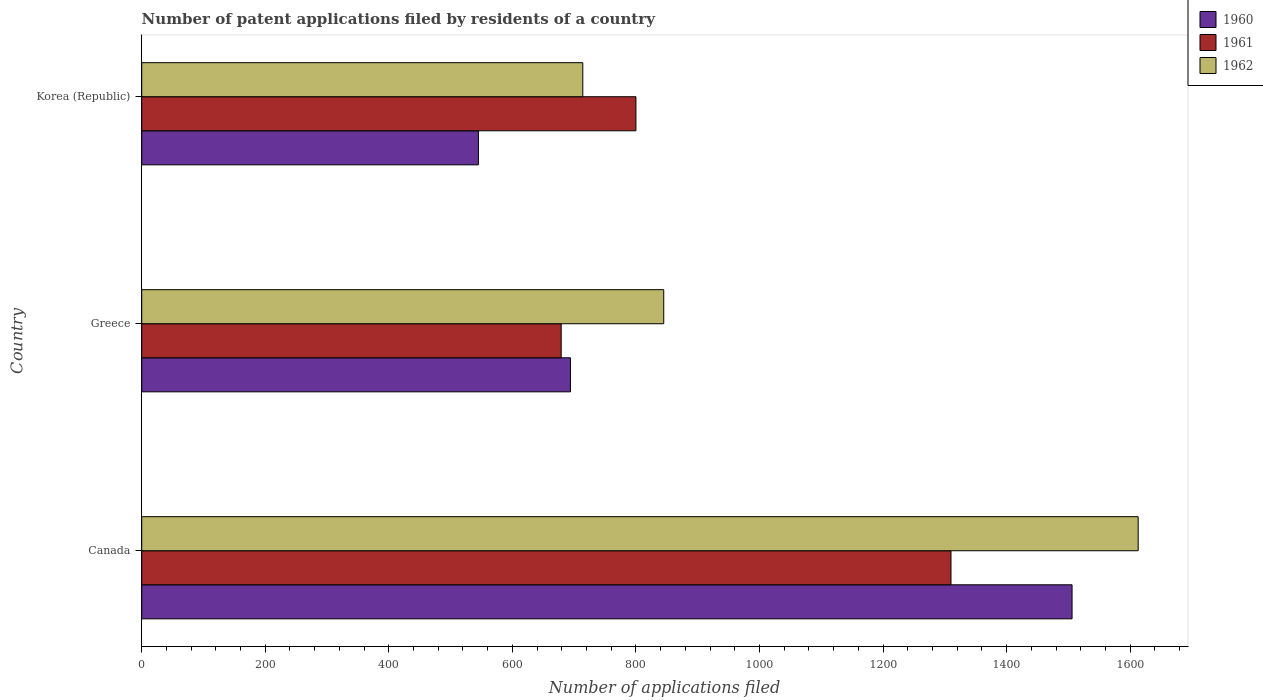How many different coloured bars are there?
Offer a very short reply. 3. What is the label of the 1st group of bars from the top?
Your answer should be very brief. Korea (Republic). What is the number of applications filed in 1962 in Greece?
Your answer should be very brief. 845. Across all countries, what is the maximum number of applications filed in 1960?
Provide a succinct answer. 1506. Across all countries, what is the minimum number of applications filed in 1960?
Provide a short and direct response. 545. What is the total number of applications filed in 1960 in the graph?
Provide a succinct answer. 2745. What is the difference between the number of applications filed in 1962 in Canada and that in Greece?
Your response must be concise. 768. What is the difference between the number of applications filed in 1960 in Canada and the number of applications filed in 1962 in Korea (Republic)?
Your response must be concise. 792. What is the average number of applications filed in 1962 per country?
Make the answer very short. 1057.33. What is the difference between the number of applications filed in 1960 and number of applications filed in 1962 in Korea (Republic)?
Provide a succinct answer. -169. In how many countries, is the number of applications filed in 1962 greater than 880 ?
Offer a terse response. 1. What is the ratio of the number of applications filed in 1962 in Greece to that in Korea (Republic)?
Provide a succinct answer. 1.18. Is the number of applications filed in 1962 in Canada less than that in Greece?
Offer a terse response. No. Is the difference between the number of applications filed in 1960 in Canada and Korea (Republic) greater than the difference between the number of applications filed in 1962 in Canada and Korea (Republic)?
Ensure brevity in your answer.  Yes. What is the difference between the highest and the second highest number of applications filed in 1962?
Offer a very short reply. 768. What is the difference between the highest and the lowest number of applications filed in 1961?
Your answer should be compact. 631. Is the sum of the number of applications filed in 1962 in Canada and Korea (Republic) greater than the maximum number of applications filed in 1960 across all countries?
Your answer should be compact. Yes. How many bars are there?
Offer a terse response. 9. Are all the bars in the graph horizontal?
Keep it short and to the point. Yes. What is the difference between two consecutive major ticks on the X-axis?
Give a very brief answer. 200. Does the graph contain any zero values?
Your answer should be compact. No. How are the legend labels stacked?
Keep it short and to the point. Vertical. What is the title of the graph?
Keep it short and to the point. Number of patent applications filed by residents of a country. Does "2001" appear as one of the legend labels in the graph?
Give a very brief answer. No. What is the label or title of the X-axis?
Offer a terse response. Number of applications filed. What is the Number of applications filed of 1960 in Canada?
Provide a succinct answer. 1506. What is the Number of applications filed of 1961 in Canada?
Make the answer very short. 1310. What is the Number of applications filed in 1962 in Canada?
Ensure brevity in your answer.  1613. What is the Number of applications filed in 1960 in Greece?
Offer a terse response. 694. What is the Number of applications filed in 1961 in Greece?
Provide a short and direct response. 679. What is the Number of applications filed of 1962 in Greece?
Your answer should be compact. 845. What is the Number of applications filed of 1960 in Korea (Republic)?
Your answer should be compact. 545. What is the Number of applications filed in 1961 in Korea (Republic)?
Your response must be concise. 800. What is the Number of applications filed in 1962 in Korea (Republic)?
Offer a very short reply. 714. Across all countries, what is the maximum Number of applications filed of 1960?
Offer a terse response. 1506. Across all countries, what is the maximum Number of applications filed in 1961?
Provide a short and direct response. 1310. Across all countries, what is the maximum Number of applications filed of 1962?
Give a very brief answer. 1613. Across all countries, what is the minimum Number of applications filed of 1960?
Your response must be concise. 545. Across all countries, what is the minimum Number of applications filed in 1961?
Make the answer very short. 679. Across all countries, what is the minimum Number of applications filed of 1962?
Your answer should be very brief. 714. What is the total Number of applications filed of 1960 in the graph?
Offer a very short reply. 2745. What is the total Number of applications filed of 1961 in the graph?
Offer a very short reply. 2789. What is the total Number of applications filed of 1962 in the graph?
Make the answer very short. 3172. What is the difference between the Number of applications filed of 1960 in Canada and that in Greece?
Offer a very short reply. 812. What is the difference between the Number of applications filed in 1961 in Canada and that in Greece?
Provide a succinct answer. 631. What is the difference between the Number of applications filed in 1962 in Canada and that in Greece?
Keep it short and to the point. 768. What is the difference between the Number of applications filed of 1960 in Canada and that in Korea (Republic)?
Keep it short and to the point. 961. What is the difference between the Number of applications filed of 1961 in Canada and that in Korea (Republic)?
Offer a very short reply. 510. What is the difference between the Number of applications filed of 1962 in Canada and that in Korea (Republic)?
Make the answer very short. 899. What is the difference between the Number of applications filed in 1960 in Greece and that in Korea (Republic)?
Ensure brevity in your answer.  149. What is the difference between the Number of applications filed of 1961 in Greece and that in Korea (Republic)?
Offer a terse response. -121. What is the difference between the Number of applications filed in 1962 in Greece and that in Korea (Republic)?
Provide a succinct answer. 131. What is the difference between the Number of applications filed of 1960 in Canada and the Number of applications filed of 1961 in Greece?
Your response must be concise. 827. What is the difference between the Number of applications filed in 1960 in Canada and the Number of applications filed in 1962 in Greece?
Keep it short and to the point. 661. What is the difference between the Number of applications filed in 1961 in Canada and the Number of applications filed in 1962 in Greece?
Ensure brevity in your answer.  465. What is the difference between the Number of applications filed in 1960 in Canada and the Number of applications filed in 1961 in Korea (Republic)?
Your answer should be very brief. 706. What is the difference between the Number of applications filed in 1960 in Canada and the Number of applications filed in 1962 in Korea (Republic)?
Make the answer very short. 792. What is the difference between the Number of applications filed of 1961 in Canada and the Number of applications filed of 1962 in Korea (Republic)?
Make the answer very short. 596. What is the difference between the Number of applications filed of 1960 in Greece and the Number of applications filed of 1961 in Korea (Republic)?
Offer a terse response. -106. What is the difference between the Number of applications filed in 1961 in Greece and the Number of applications filed in 1962 in Korea (Republic)?
Give a very brief answer. -35. What is the average Number of applications filed of 1960 per country?
Make the answer very short. 915. What is the average Number of applications filed in 1961 per country?
Your answer should be very brief. 929.67. What is the average Number of applications filed of 1962 per country?
Ensure brevity in your answer.  1057.33. What is the difference between the Number of applications filed of 1960 and Number of applications filed of 1961 in Canada?
Your answer should be very brief. 196. What is the difference between the Number of applications filed of 1960 and Number of applications filed of 1962 in Canada?
Provide a succinct answer. -107. What is the difference between the Number of applications filed in 1961 and Number of applications filed in 1962 in Canada?
Keep it short and to the point. -303. What is the difference between the Number of applications filed in 1960 and Number of applications filed in 1961 in Greece?
Your answer should be compact. 15. What is the difference between the Number of applications filed of 1960 and Number of applications filed of 1962 in Greece?
Provide a short and direct response. -151. What is the difference between the Number of applications filed in 1961 and Number of applications filed in 1962 in Greece?
Keep it short and to the point. -166. What is the difference between the Number of applications filed of 1960 and Number of applications filed of 1961 in Korea (Republic)?
Offer a terse response. -255. What is the difference between the Number of applications filed in 1960 and Number of applications filed in 1962 in Korea (Republic)?
Provide a succinct answer. -169. What is the difference between the Number of applications filed in 1961 and Number of applications filed in 1962 in Korea (Republic)?
Your response must be concise. 86. What is the ratio of the Number of applications filed of 1960 in Canada to that in Greece?
Your response must be concise. 2.17. What is the ratio of the Number of applications filed of 1961 in Canada to that in Greece?
Offer a very short reply. 1.93. What is the ratio of the Number of applications filed of 1962 in Canada to that in Greece?
Your answer should be very brief. 1.91. What is the ratio of the Number of applications filed in 1960 in Canada to that in Korea (Republic)?
Offer a terse response. 2.76. What is the ratio of the Number of applications filed of 1961 in Canada to that in Korea (Republic)?
Give a very brief answer. 1.64. What is the ratio of the Number of applications filed in 1962 in Canada to that in Korea (Republic)?
Provide a succinct answer. 2.26. What is the ratio of the Number of applications filed of 1960 in Greece to that in Korea (Republic)?
Your answer should be compact. 1.27. What is the ratio of the Number of applications filed of 1961 in Greece to that in Korea (Republic)?
Offer a very short reply. 0.85. What is the ratio of the Number of applications filed in 1962 in Greece to that in Korea (Republic)?
Provide a succinct answer. 1.18. What is the difference between the highest and the second highest Number of applications filed in 1960?
Provide a short and direct response. 812. What is the difference between the highest and the second highest Number of applications filed of 1961?
Provide a succinct answer. 510. What is the difference between the highest and the second highest Number of applications filed in 1962?
Keep it short and to the point. 768. What is the difference between the highest and the lowest Number of applications filed of 1960?
Keep it short and to the point. 961. What is the difference between the highest and the lowest Number of applications filed in 1961?
Offer a terse response. 631. What is the difference between the highest and the lowest Number of applications filed in 1962?
Give a very brief answer. 899. 